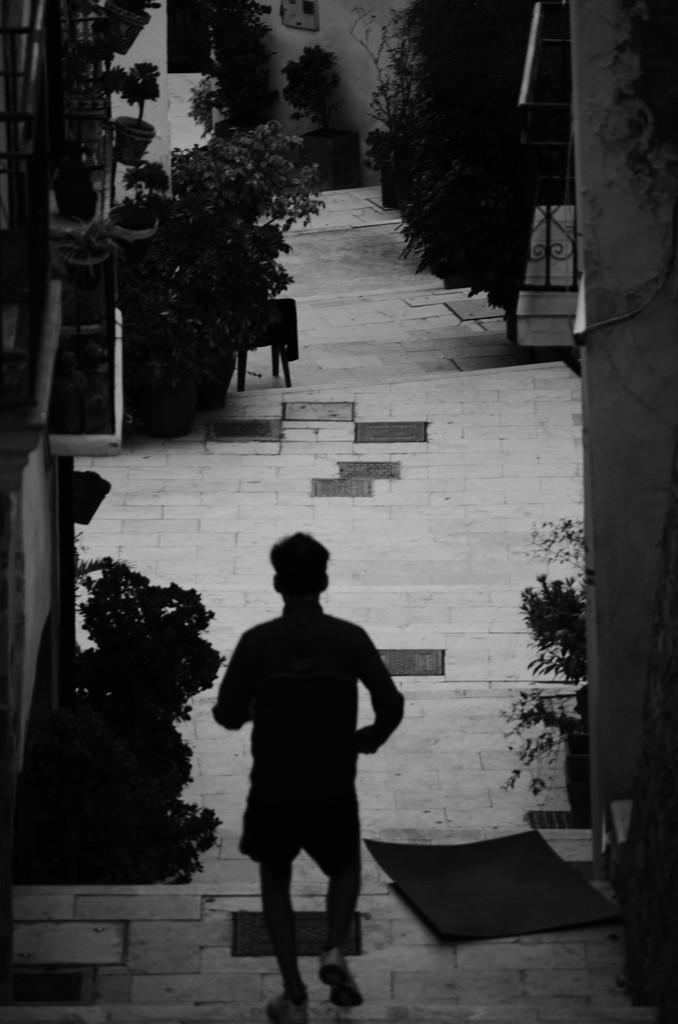What is the person in the image doing? The person is walking in the image. Where is the person walking? The person is walking on a street. What can be seen on both sides of the street? There are plants and trees on both sides of the street. What type of structures are present on both sides of the street? There are buildings on both sides of the street. Can you tell me how many beetles are crawling on the person's shoes in the image? There are no beetles present in the image; the person is simply walking on the street. 